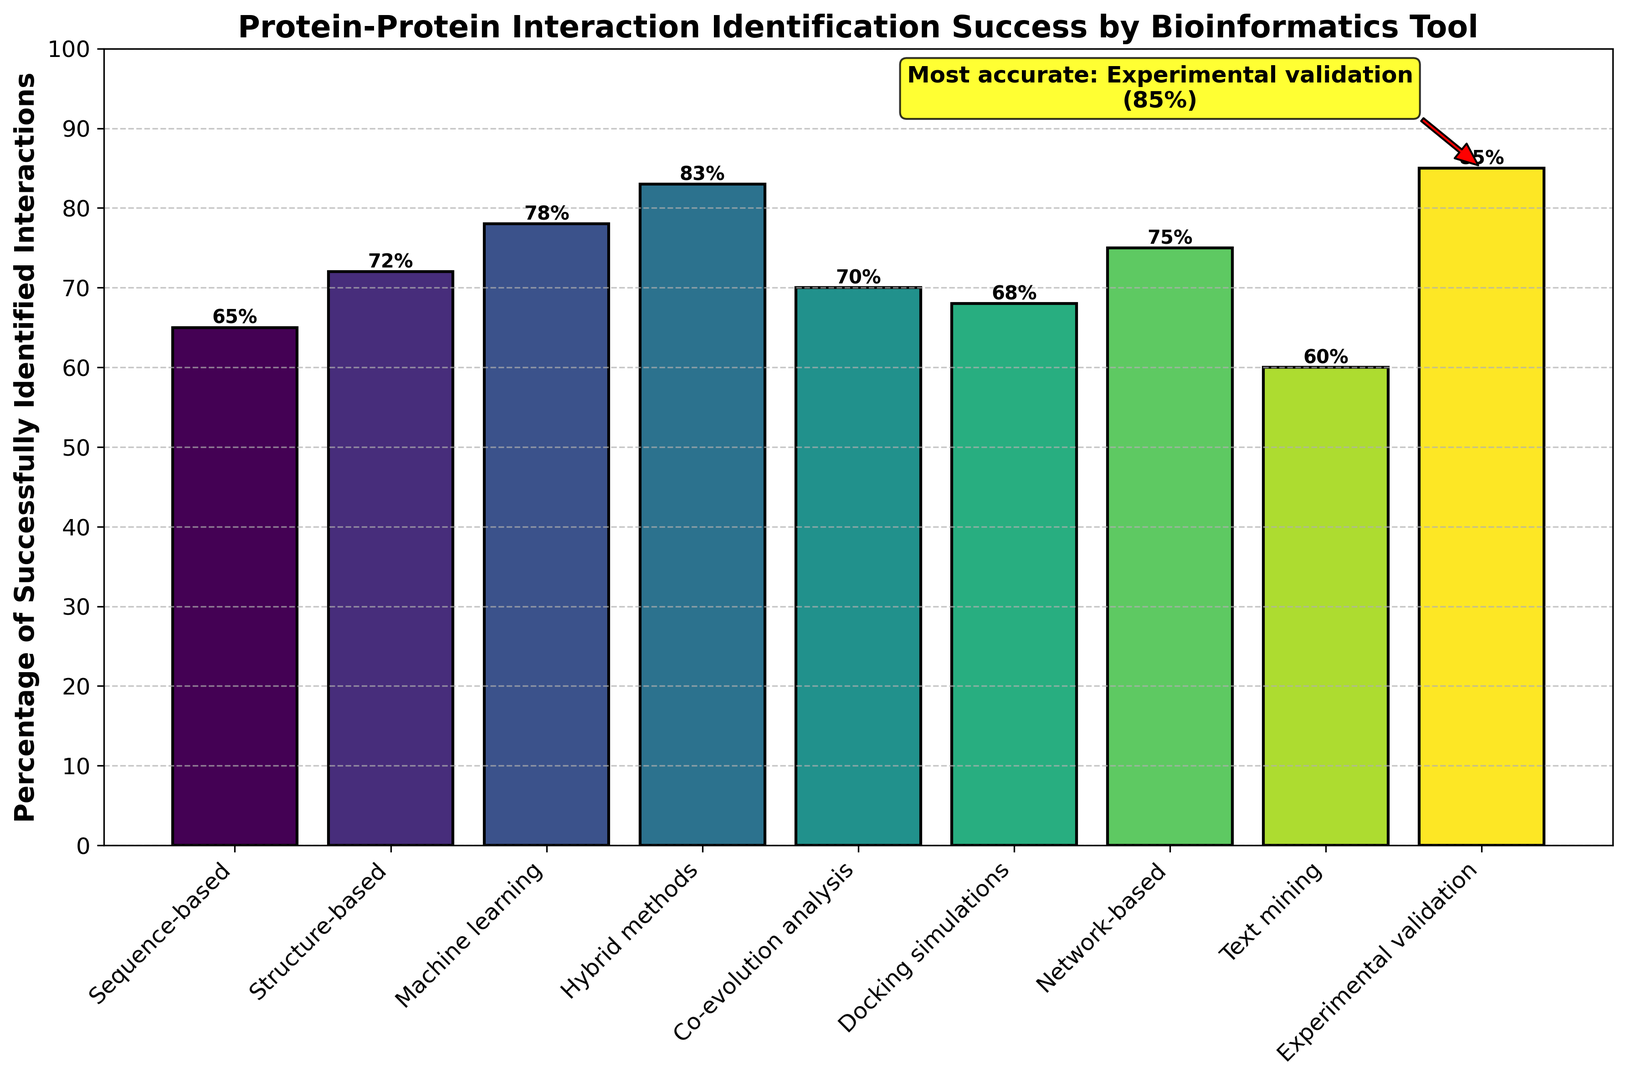what is the most accurate method for identifying protein-protein interactions? The annotation in the figure highlights the most accurate method, indicating "Experimental validation" with a percentage of 85%.
Answer: Experimental validation What is the difference in identification success between the least and most accurate methods? The least accurate method is "Text mining" with 60%, and the most accurate method is "Experimental validation" with 85%. The difference is 85% - 60% = 25%.
Answer: 25% Which method has the second highest percentage of successful identification? After "Experimental validation" (85%), the next highest is "Hybrid methods" with 83%. This can be identified by examining and comparing the heights of all bars.
Answer: Hybrid methods What is the combined percentage of success for structure-based and machine learning methods? Structure-based (72%) + Machine learning (78%) = 150%. Adding the two respective percentages from the bars provides the total percentage.
Answer: 150% Between "network-based" and "co-evolution analysis" methods, which is more effective and by how much? "Network-based" has a success rate of 75%, while "Co-evolution analysis" has 70%. The difference is 75% - 70% = 5%.
Answer: Network-based, 5% How does the success of "Docking simulations" compare to "Sequence-based" methods? "Docking simulations" has a success rate of 68%, while "Sequence-based" has 65%. Docking simulations are 3% more effective.
Answer: Docking simulations, 3% What is the average percentage of successful identification across all methods? Summing up all percentages (65 + 72 + 78 + 83 + 70 + 68 + 75 + 60 + 85) gives 656. Dividing this by the number of methods (9) gives 656 / 9 ≈ 72.89%.
Answer: ~72.89% Which method had the closest success rate to the overall average? The calculated average success rate is roughly 72.89%. The closest method is "Structure-based" with 72%. This requires comparing all percentages to the average.
Answer: Structure-based What is the total percentage of successful identification for all methods exceeding 70%? The methods exceeding 70% are Structure-based (72%), Machine learning (78%), Hybrid methods (83%), Network-based (75%), and Experimental validation (85%). Summing these gives 72 + 78 + 83 + 75 + 85 = 393%.
Answer: 393% 